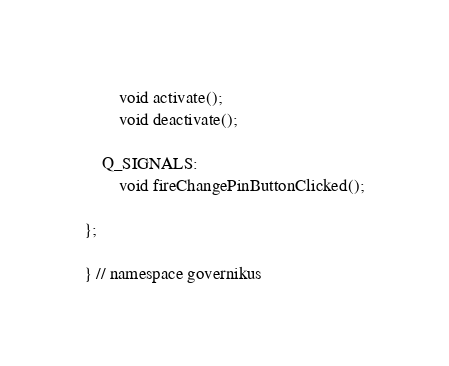Convert code to text. <code><loc_0><loc_0><loc_500><loc_500><_C_>		void activate();
		void deactivate();

	Q_SIGNALS:
		void fireChangePinButtonClicked();

};

} // namespace governikus
</code> 